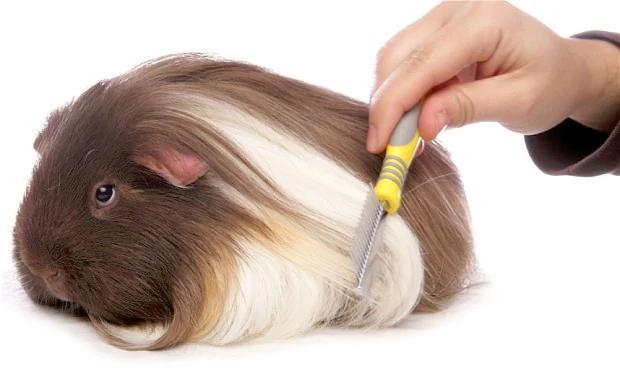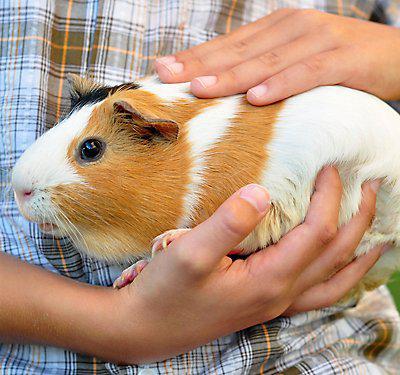The first image is the image on the left, the second image is the image on the right. For the images shown, is this caption "A person is holding one of the animals." true? Answer yes or no. Yes. 